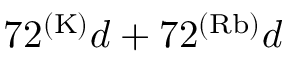Convert formula to latex. <formula><loc_0><loc_0><loc_500><loc_500>7 2 ^ { ( K ) } d + 7 2 ^ { ( R b ) } d</formula> 